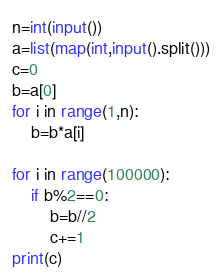Convert code to text. <code><loc_0><loc_0><loc_500><loc_500><_Python_>n=int(input())
a=list(map(int,input().split()))
c=0
b=a[0]
for i in range(1,n):
    b=b*a[i]

for i in range(100000):
    if b%2==0:
        b=b//2
        c+=1
print(c)</code> 